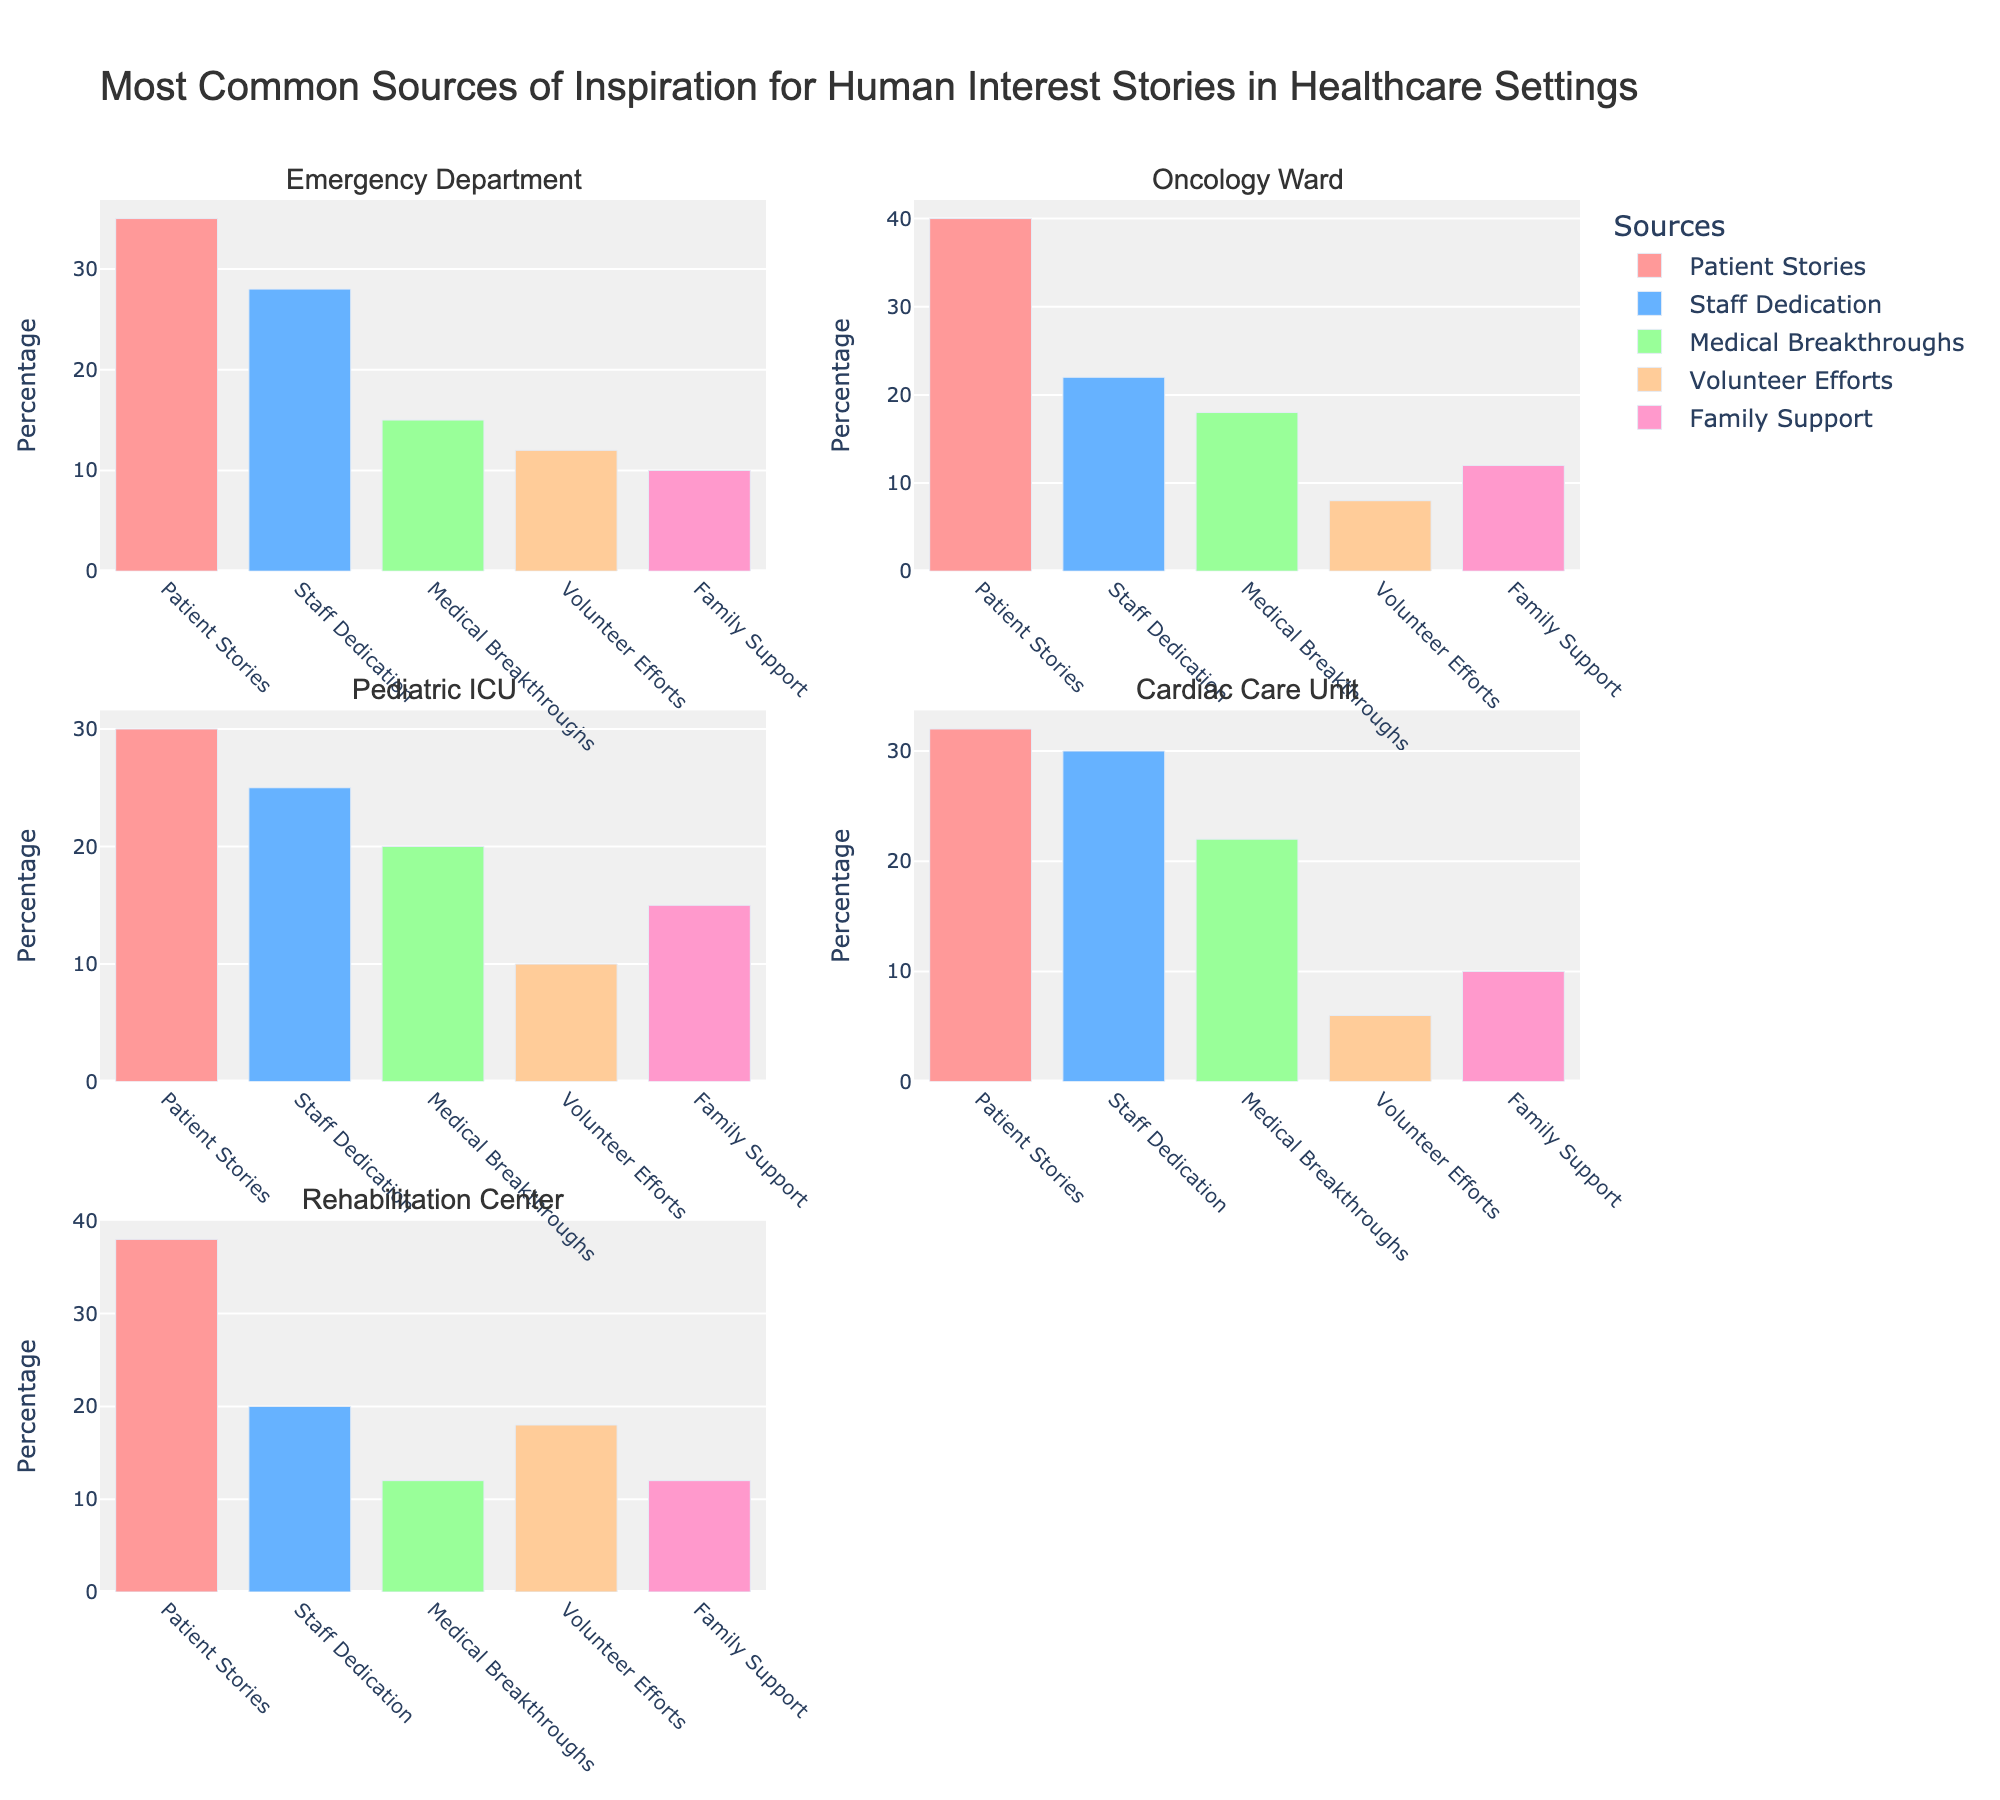What's the title of the figure? The title of the figure is usually located at the top of the plot. In this case, the title is "Most Common Sources of Inspiration for Human Interest Stories in Healthcare Settings".
Answer: Most Common Sources of Inspiration for Human Interest Stories in Healthcare Settings Which category has the highest value for patient stories? To find this, examine the bar that represents patient stories within each subplot. The Oncology Ward category has the highest value for patient stories, which is 40.
Answer: Oncology Ward How many categories have values greater than 30 for patient stories? Look at the values for patient stories in each category. The categories are Emergency Department (35), Oncology Ward (40), Pediatric ICU (30), Cardiac Care Unit (32), and Rehabilitation Center (38). There are 4 categories with values greater than 30.
Answer: 4 Which source of inspiration is least common in the Cardiac Care Unit? Within the subplot for the Cardiac Care Unit, identify the bar with the smallest value. Volunteer Efforts has the lowest value, which is 6.
Answer: Volunteer Efforts What is the total value for staff dedication across all categories? Sum up the values for staff dedication from all categories: 28 (Emergency Department) + 22 (Oncology Ward) + 25 (Pediatric ICU) + 30 (Cardiac Care Unit) + 20 (Rehabilitation Center) = 125.
Answer: 125 Compare the values of medical breakthroughs between Emergency Department and Pediatric ICU. Which has a higher value and by how much? The value for medical breakthroughs in the Emergency Department is 15, and in the Pediatric ICU, it is 20. The Pediatric ICU has a higher value by 5.
Answer: Pediatric ICU by 5 What is the average value of family support across all categories? Calculate the mean by summing the values for family support across all categories and dividing by the number of categories: (10 + 12 + 15 + 10 + 12) / 5 = 59 / 5 = 11.8.
Answer: 11.8 Which category has the closest values for patient stories and staff dedication? Compare the differences in values for patient stories and staff dedication across categories. Pediatric ICU has patient stories (30) and staff dedication (25) with the closest difference of 5.
Answer: Pediatric ICU What is the difference between the highest and lowest values for volunteer efforts across all categories? Identify the highest value for volunteer efforts, which is 18 (Rehabilitation Center), and the lowest value, which is 6 (Cardiac Care Unit). The difference is 18 - 6 = 12.
Answer: 12 